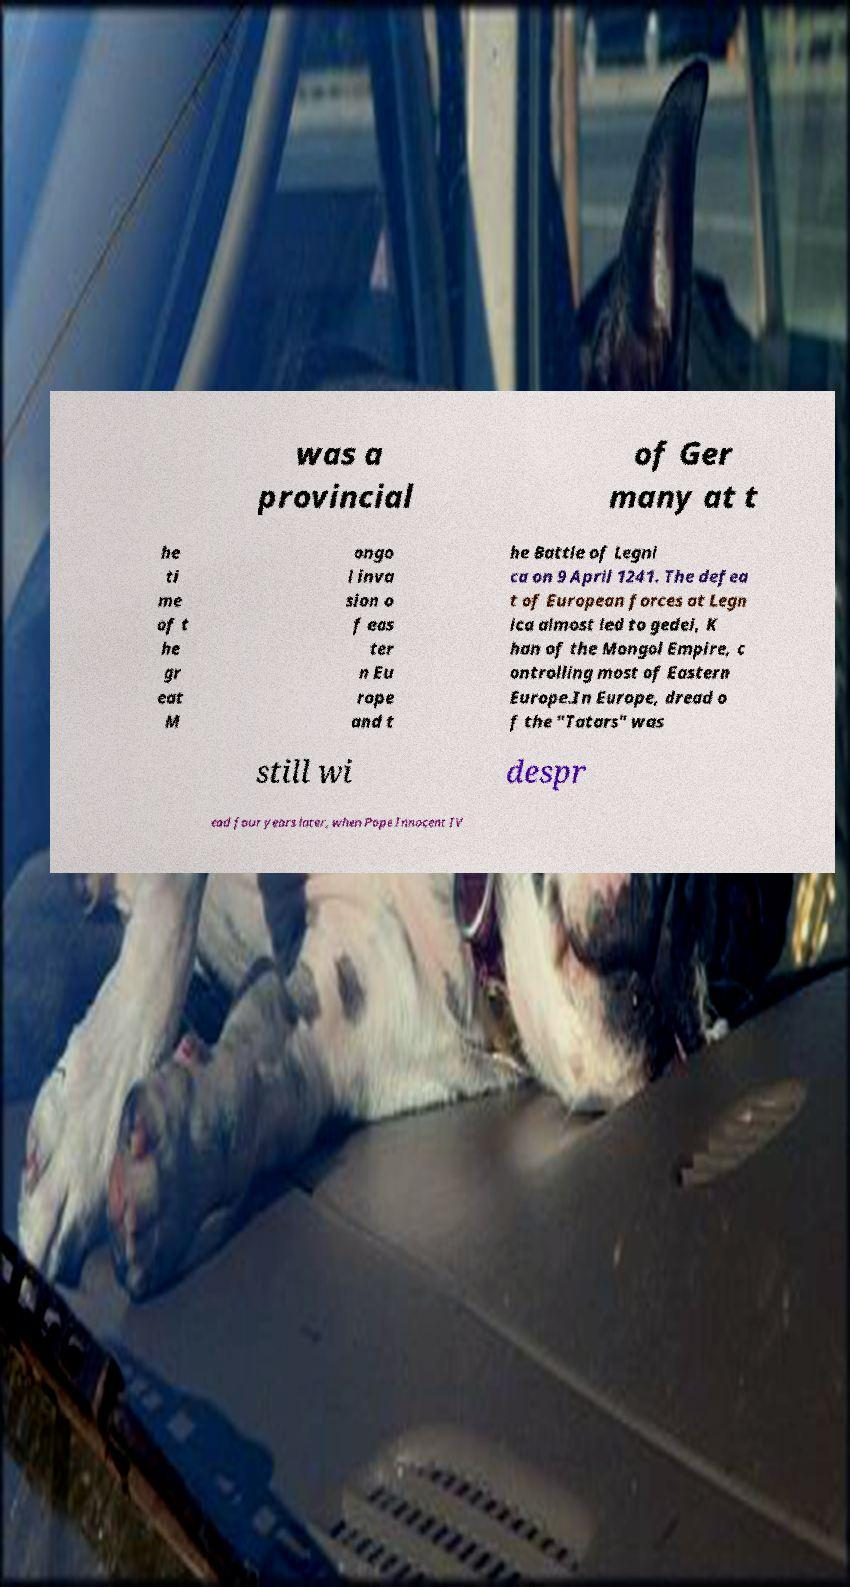What messages or text are displayed in this image? I need them in a readable, typed format. was a provincial of Ger many at t he ti me of t he gr eat M ongo l inva sion o f eas ter n Eu rope and t he Battle of Legni ca on 9 April 1241. The defea t of European forces at Legn ica almost led to gedei, K han of the Mongol Empire, c ontrolling most of Eastern Europe.In Europe, dread o f the "Tatars" was still wi despr ead four years later, when Pope Innocent IV 